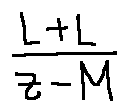Convert formula to latex. <formula><loc_0><loc_0><loc_500><loc_500>\frac { L + L } { z - M }</formula> 